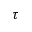Convert formula to latex. <formula><loc_0><loc_0><loc_500><loc_500>\tau</formula> 